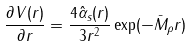<formula> <loc_0><loc_0><loc_500><loc_500>\frac { \partial V ( r ) } { \partial r } = \frac { 4 \hat { \alpha } _ { s } ( r ) } { 3 r ^ { 2 } } \exp ( - \bar { M } _ { \rho } r )</formula> 